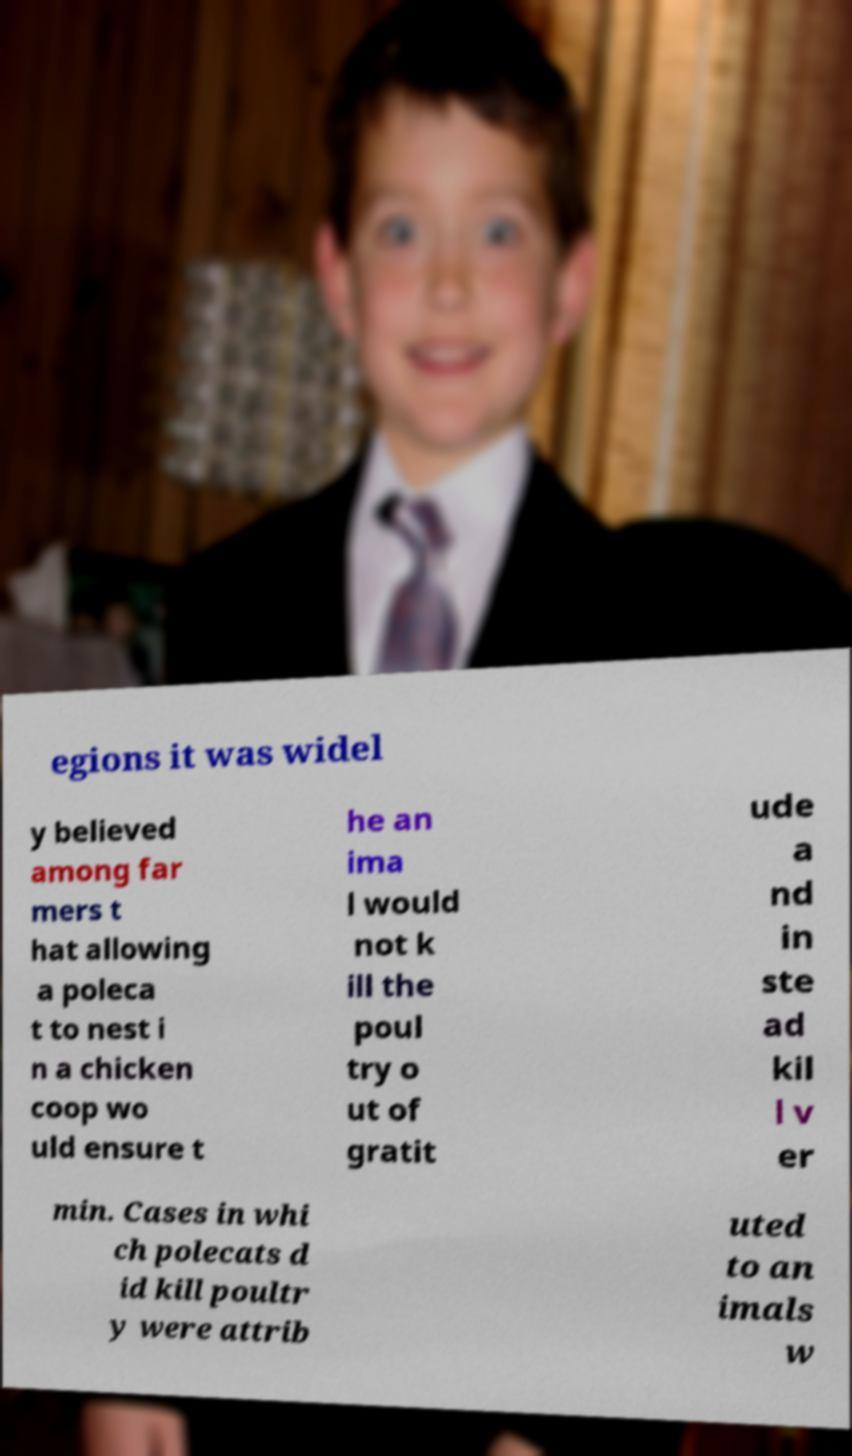Can you read and provide the text displayed in the image?This photo seems to have some interesting text. Can you extract and type it out for me? egions it was widel y believed among far mers t hat allowing a poleca t to nest i n a chicken coop wo uld ensure t he an ima l would not k ill the poul try o ut of gratit ude a nd in ste ad kil l v er min. Cases in whi ch polecats d id kill poultr y were attrib uted to an imals w 